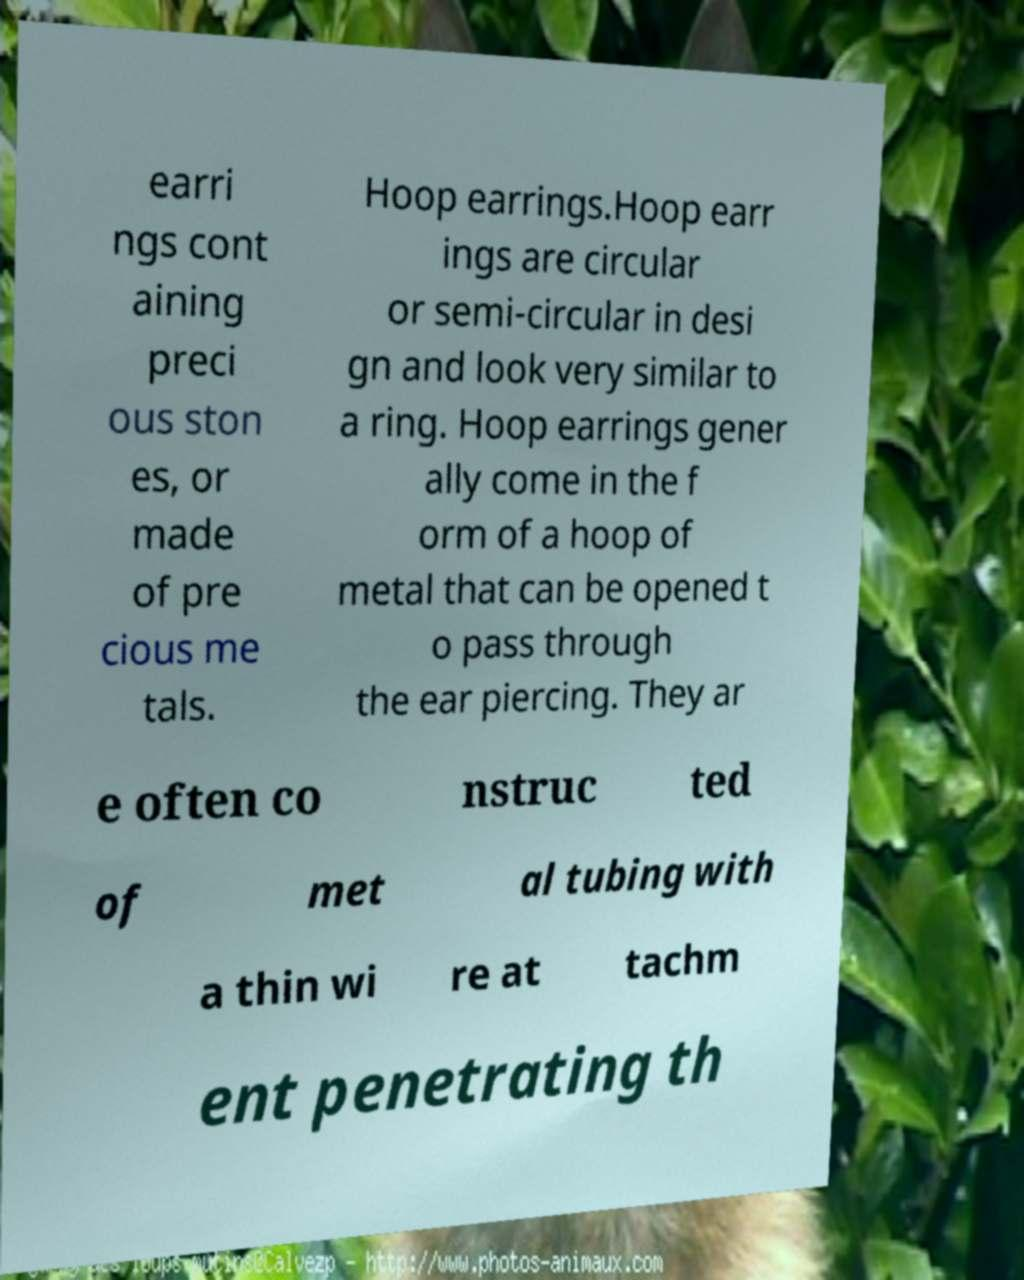Can you accurately transcribe the text from the provided image for me? earri ngs cont aining preci ous ston es, or made of pre cious me tals. Hoop earrings.Hoop earr ings are circular or semi-circular in desi gn and look very similar to a ring. Hoop earrings gener ally come in the f orm of a hoop of metal that can be opened t o pass through the ear piercing. They ar e often co nstruc ted of met al tubing with a thin wi re at tachm ent penetrating th 